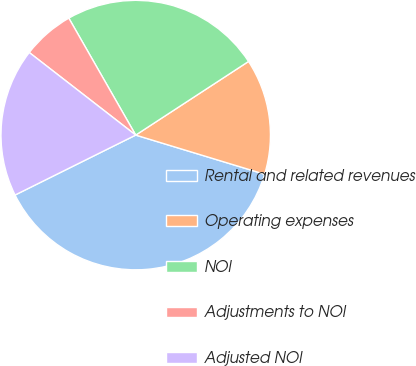Convert chart. <chart><loc_0><loc_0><loc_500><loc_500><pie_chart><fcel>Rental and related revenues<fcel>Operating expenses<fcel>NOI<fcel>Adjustments to NOI<fcel>Adjusted NOI<nl><fcel>37.97%<fcel>13.9%<fcel>24.07%<fcel>6.23%<fcel>17.84%<nl></chart> 